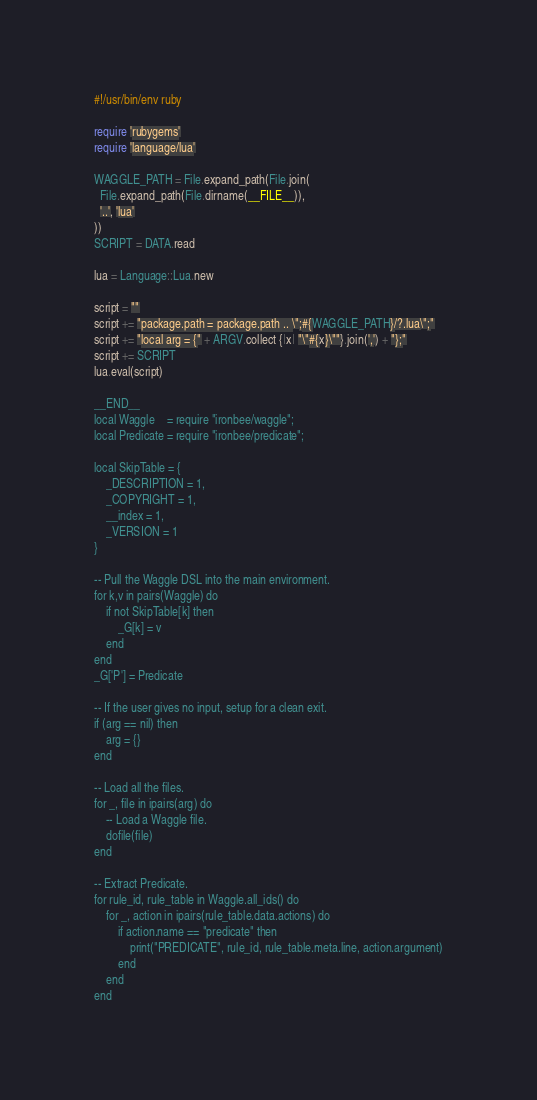<code> <loc_0><loc_0><loc_500><loc_500><_Ruby_>#!/usr/bin/env ruby

require 'rubygems'
require 'language/lua'

WAGGLE_PATH = File.expand_path(File.join(
  File.expand_path(File.dirname(__FILE__)),
  '..', 'lua'
))
SCRIPT = DATA.read

lua = Language::Lua.new

script = ""
script += "package.path = package.path .. \";#{WAGGLE_PATH}/?.lua\";"
script += "local arg = {" + ARGV.collect {|x| "\"#{x}\""}.join(',') + "};"
script += SCRIPT
lua.eval(script)

__END__
local Waggle    = require "ironbee/waggle";
local Predicate = require "ironbee/predicate";

local SkipTable = {
    _DESCRIPTION = 1,
    _COPYRIGHT = 1,
    __index = 1,
    _VERSION = 1
}

-- Pull the Waggle DSL into the main environment.
for k,v in pairs(Waggle) do
    if not SkipTable[k] then
        _G[k] = v
    end
end
_G['P'] = Predicate

-- If the user gives no input, setup for a clean exit.
if (arg == nil) then
    arg = {}
end

-- Load all the files.
for _, file in ipairs(arg) do
    -- Load a Waggle file.
    dofile(file)
end

-- Extract Predicate.
for rule_id, rule_table in Waggle.all_ids() do
    for _, action in ipairs(rule_table.data.actions) do
        if action.name == "predicate" then
            print("PREDICATE", rule_id, rule_table.meta.line, action.argument)
        end
    end
end
</code> 